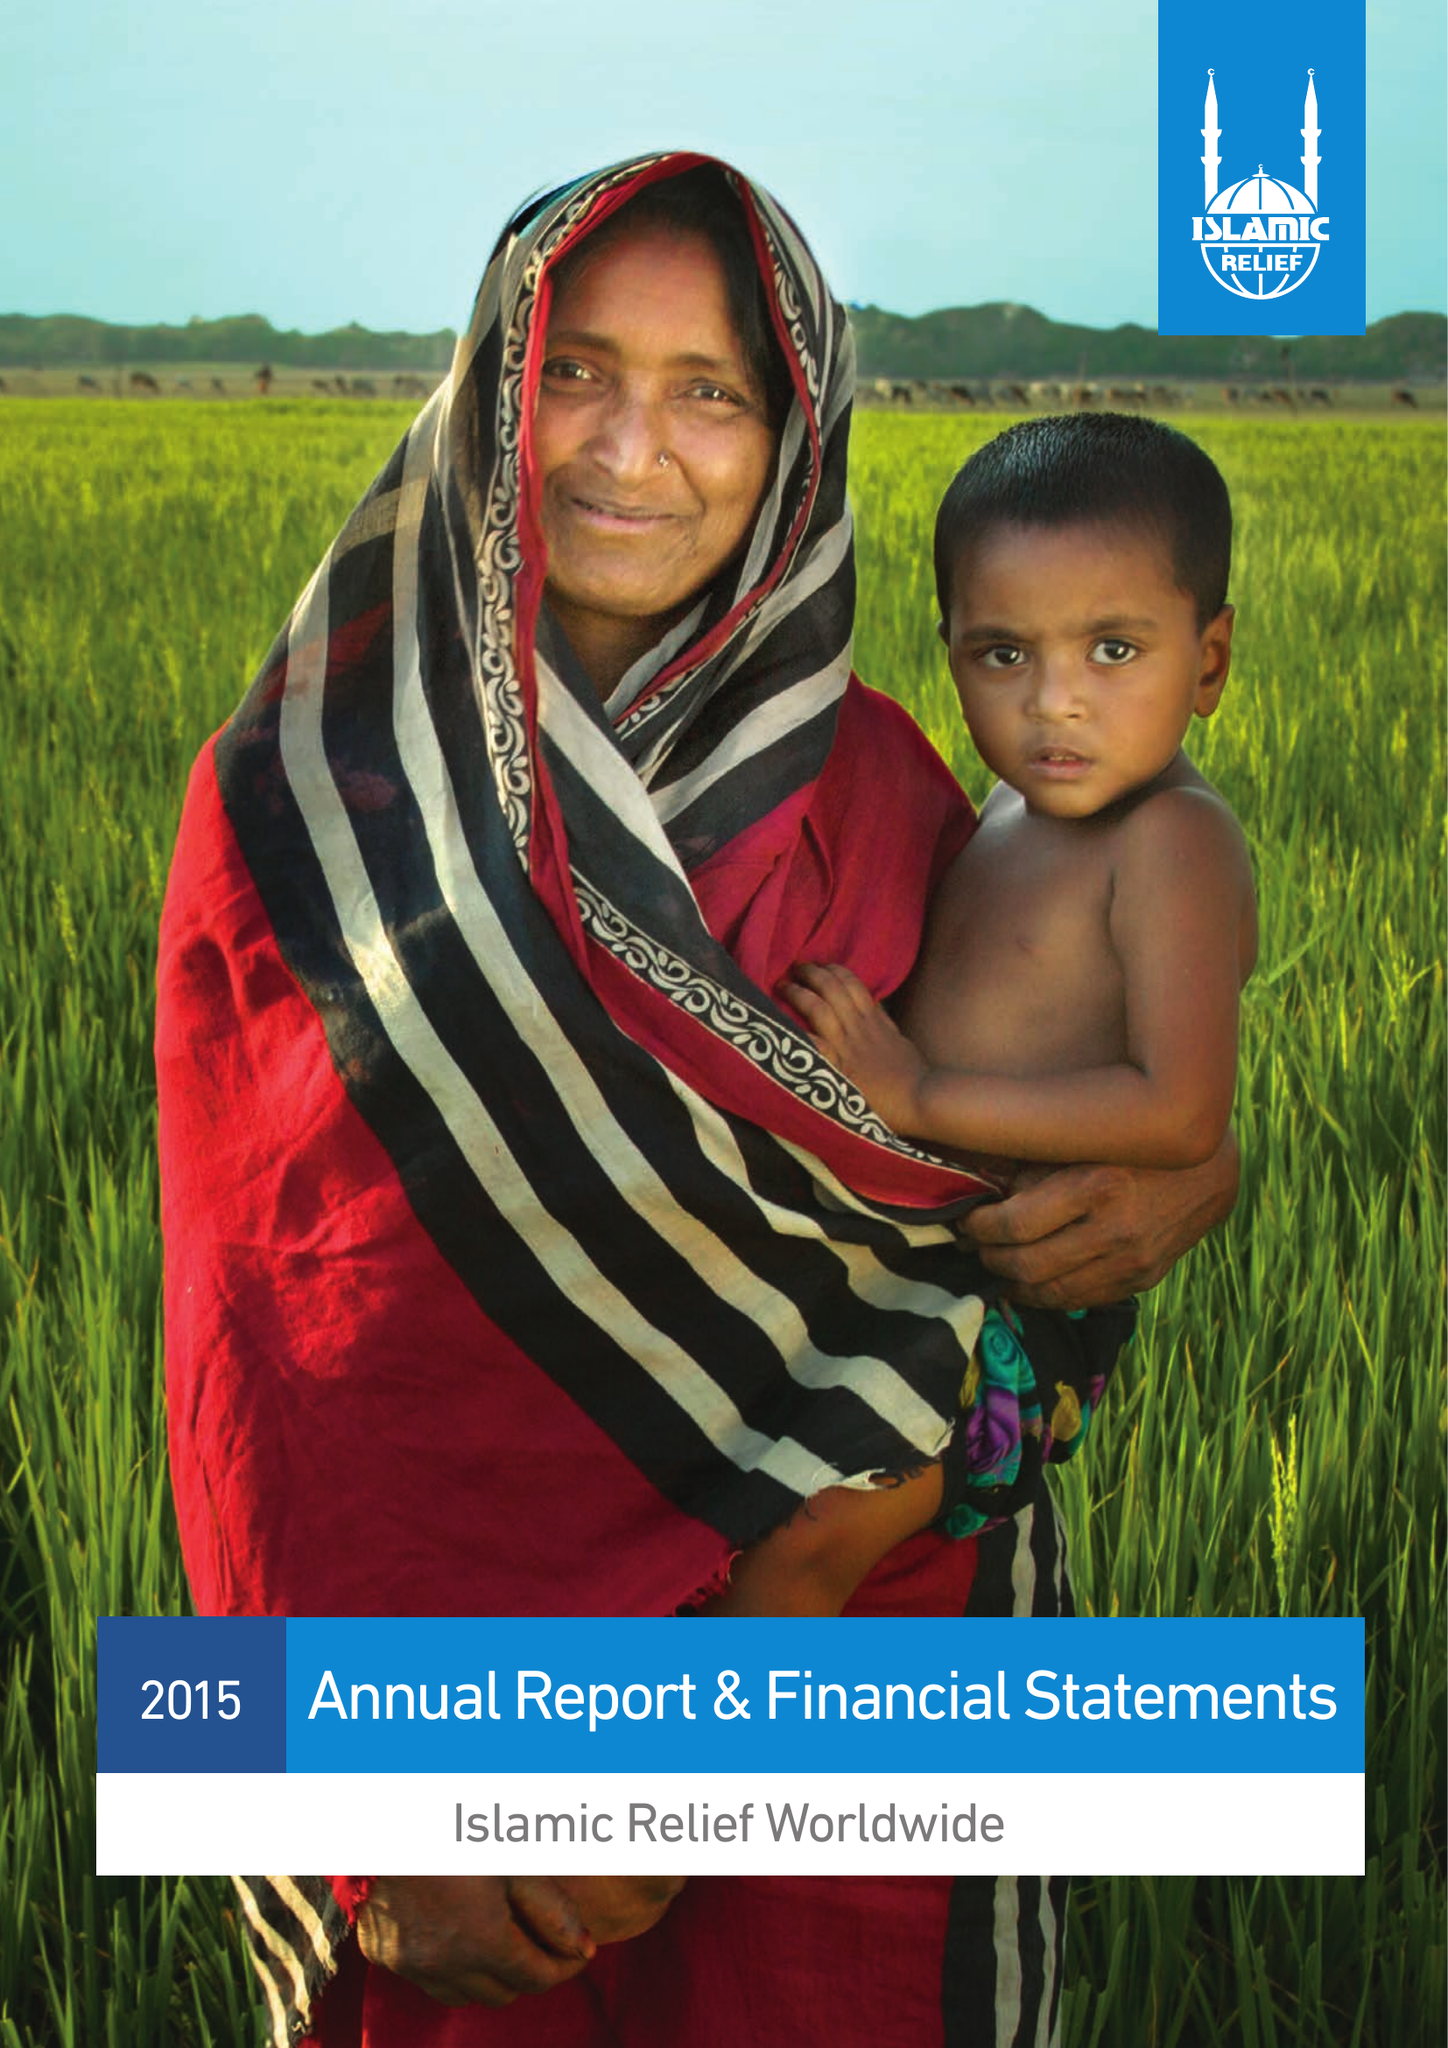What is the value for the charity_number?
Answer the question using a single word or phrase. 328158 